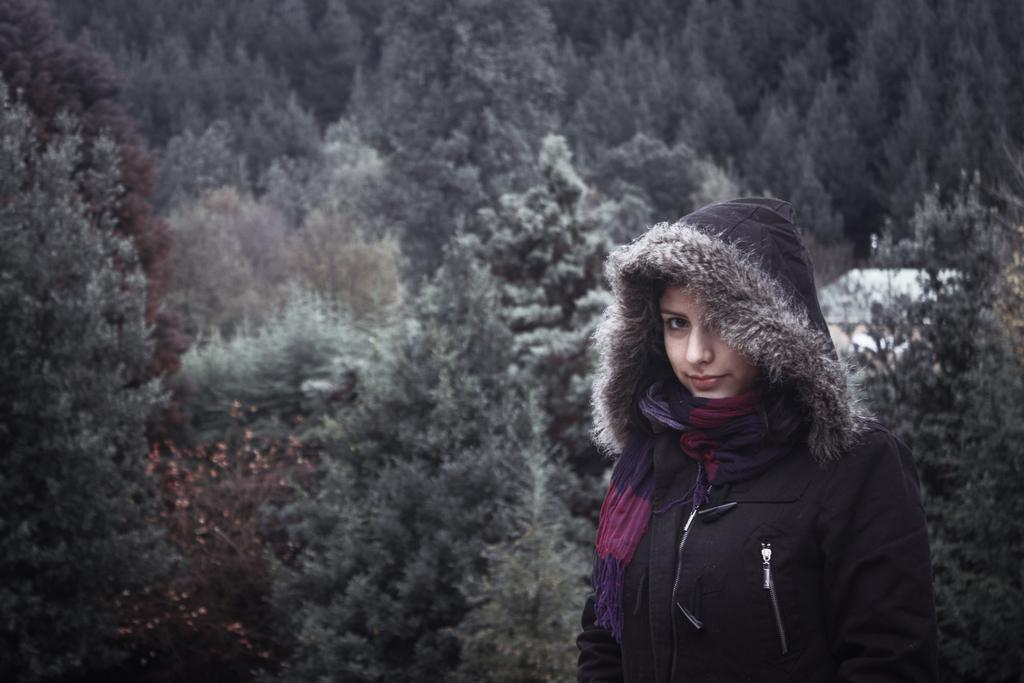What is the main subject in the foreground of the image? There is a woman standing in the foreground of the image. What can be seen in the background of the image? There are trees in the background of the image. What type of advice is the woman giving to the birds in the image? There are no birds present in the image, so the woman cannot be giving advice to any birds. 